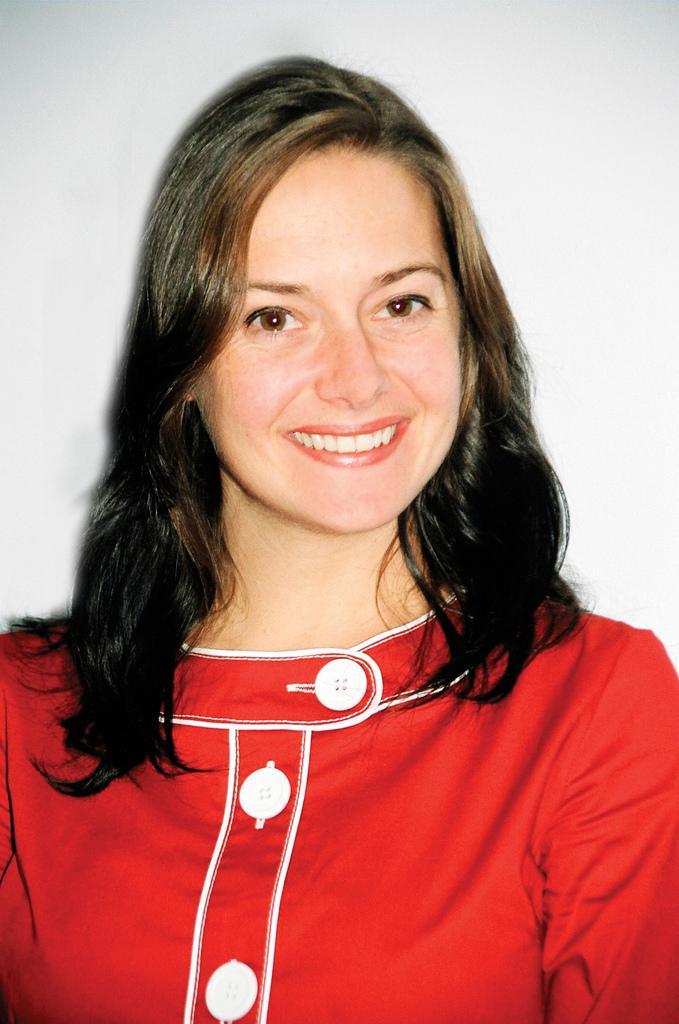Could you give a brief overview of what you see in this image? In this picture there is a woman who is wearing red dress and she is smiling. In the back there is a wall. 